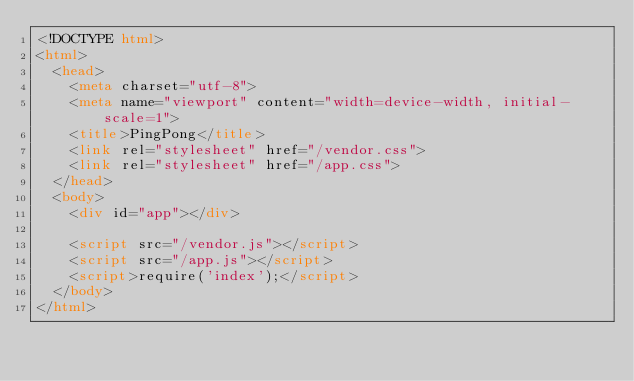Convert code to text. <code><loc_0><loc_0><loc_500><loc_500><_HTML_><!DOCTYPE html>
<html>
  <head>
    <meta charset="utf-8">
    <meta name="viewport" content="width=device-width, initial-scale=1">
    <title>PingPong</title>
    <link rel="stylesheet" href="/vendor.css">
    <link rel="stylesheet" href="/app.css">
  </head>
  <body>
    <div id="app"></div>

    <script src="/vendor.js"></script>
    <script src="/app.js"></script>
    <script>require('index');</script>
  </body>
</html>
</code> 